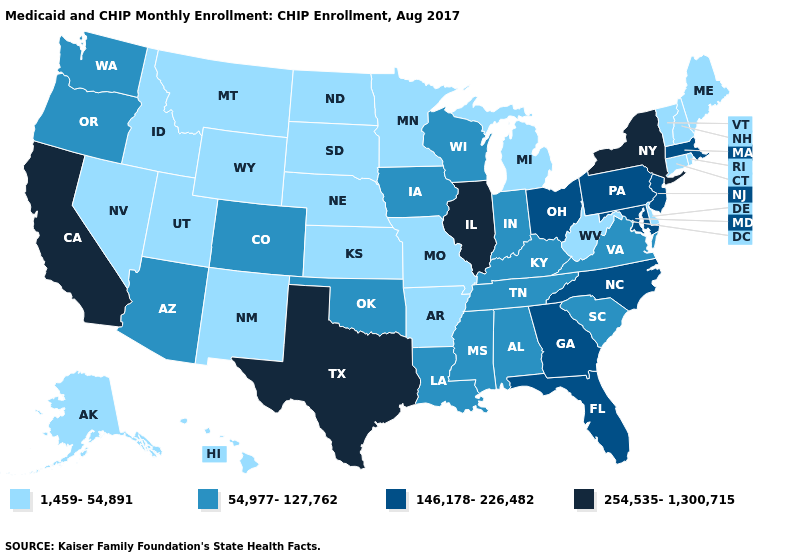Does California have the lowest value in the West?
Concise answer only. No. Name the states that have a value in the range 1,459-54,891?
Give a very brief answer. Alaska, Arkansas, Connecticut, Delaware, Hawaii, Idaho, Kansas, Maine, Michigan, Minnesota, Missouri, Montana, Nebraska, Nevada, New Hampshire, New Mexico, North Dakota, Rhode Island, South Dakota, Utah, Vermont, West Virginia, Wyoming. Does Delaware have the same value as Missouri?
Quick response, please. Yes. What is the value of New Jersey?
Give a very brief answer. 146,178-226,482. Which states hav the highest value in the South?
Short answer required. Texas. What is the value of Arkansas?
Concise answer only. 1,459-54,891. What is the highest value in the USA?
Write a very short answer. 254,535-1,300,715. What is the lowest value in the USA?
Keep it brief. 1,459-54,891. Name the states that have a value in the range 1,459-54,891?
Concise answer only. Alaska, Arkansas, Connecticut, Delaware, Hawaii, Idaho, Kansas, Maine, Michigan, Minnesota, Missouri, Montana, Nebraska, Nevada, New Hampshire, New Mexico, North Dakota, Rhode Island, South Dakota, Utah, Vermont, West Virginia, Wyoming. Does Illinois have the highest value in the USA?
Give a very brief answer. Yes. Among the states that border Wyoming , does Colorado have the highest value?
Answer briefly. Yes. Does Rhode Island have the highest value in the Northeast?
Short answer required. No. What is the value of Iowa?
Answer briefly. 54,977-127,762. What is the value of Kentucky?
Quick response, please. 54,977-127,762. Does Hawaii have the lowest value in the USA?
Short answer required. Yes. 